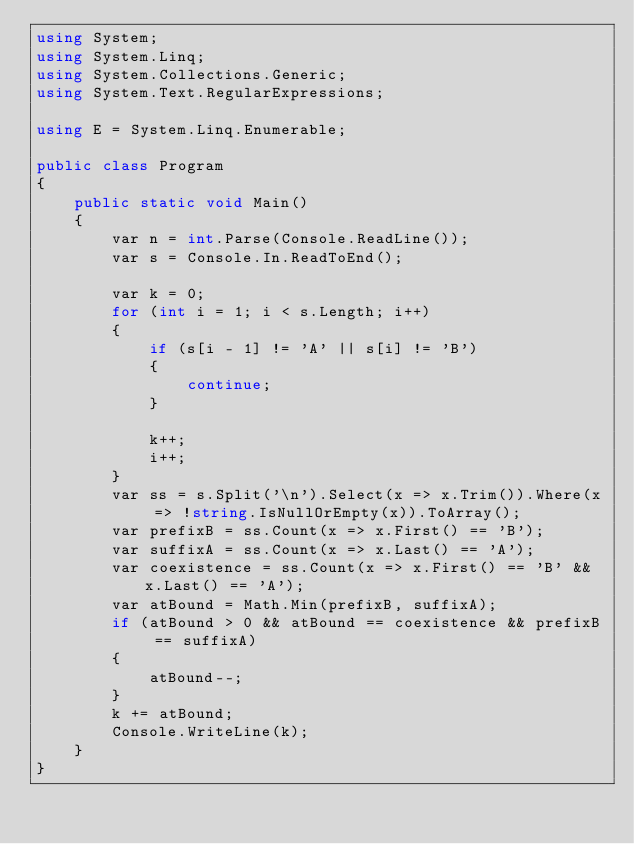<code> <loc_0><loc_0><loc_500><loc_500><_C#_>using System;
using System.Linq;
using System.Collections.Generic;
using System.Text.RegularExpressions;

using E = System.Linq.Enumerable;

public class Program
{
    public static void Main()
    {
        var n = int.Parse(Console.ReadLine());
        var s = Console.In.ReadToEnd();

        var k = 0;
        for (int i = 1; i < s.Length; i++)
        {
            if (s[i - 1] != 'A' || s[i] != 'B')
            {
                continue;
            }

            k++;
            i++;
        }
        var ss = s.Split('\n').Select(x => x.Trim()).Where(x => !string.IsNullOrEmpty(x)).ToArray();
        var prefixB = ss.Count(x => x.First() == 'B');
        var suffixA = ss.Count(x => x.Last() == 'A');
        var coexistence = ss.Count(x => x.First() == 'B' && x.Last() == 'A');
        var atBound = Math.Min(prefixB, suffixA);
        if (atBound > 0 && atBound == coexistence && prefixB == suffixA)
        {
            atBound--;
        }
        k += atBound;
        Console.WriteLine(k);
    }
}
</code> 